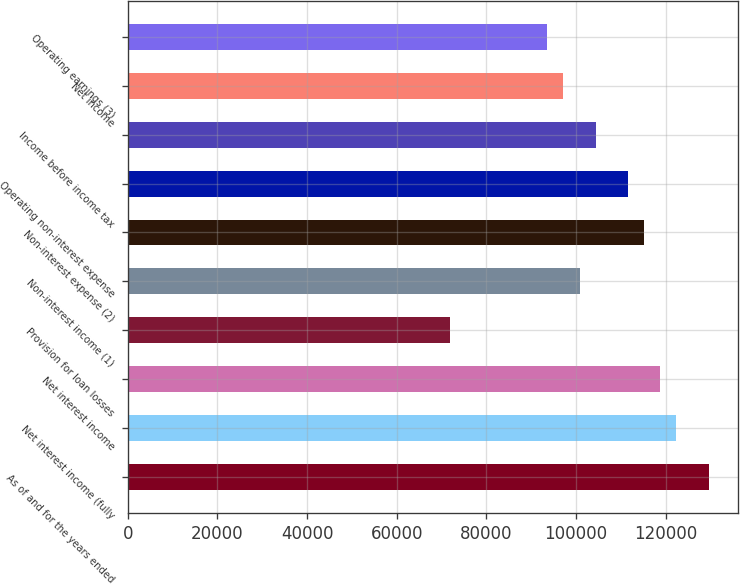Convert chart to OTSL. <chart><loc_0><loc_0><loc_500><loc_500><bar_chart><fcel>As of and for the years ended<fcel>Net interest income (fully<fcel>Net interest income<fcel>Provision for loan losses<fcel>Non-interest income (1)<fcel>Non-interest expense (2)<fcel>Operating non-interest expense<fcel>Income before income tax<fcel>Net income<fcel>Operating earnings (3)<nl><fcel>129589<fcel>122390<fcel>118790<fcel>71993.9<fcel>100791<fcel>115190<fcel>111591<fcel>104391<fcel>97191.8<fcel>93592.1<nl></chart> 